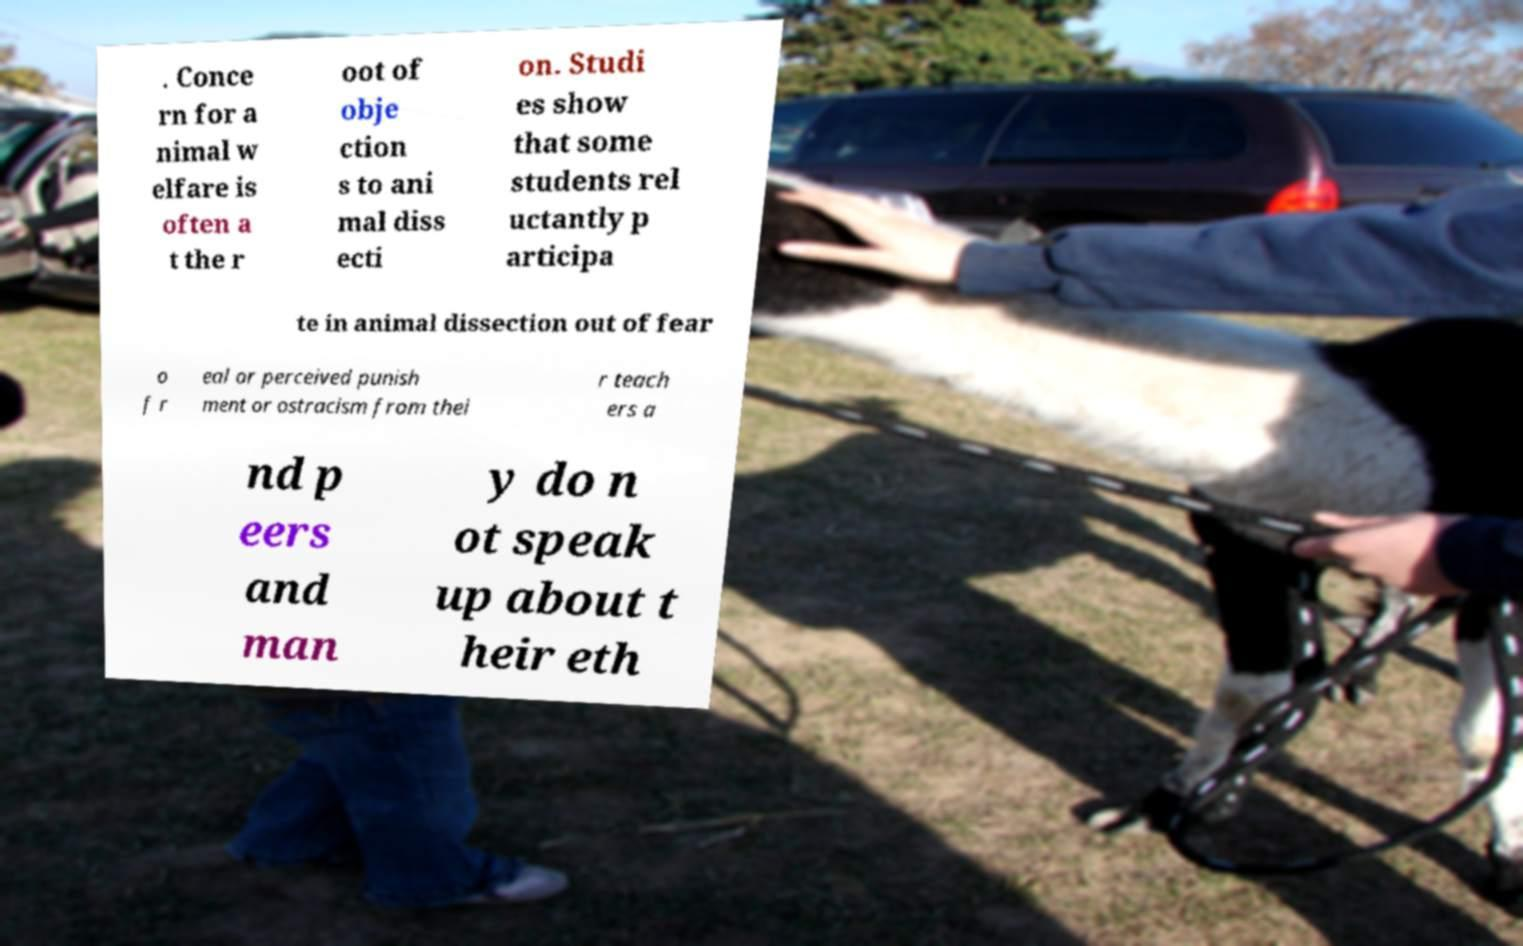Could you extract and type out the text from this image? . Conce rn for a nimal w elfare is often a t the r oot of obje ction s to ani mal diss ecti on. Studi es show that some students rel uctantly p articipa te in animal dissection out of fear o f r eal or perceived punish ment or ostracism from thei r teach ers a nd p eers and man y do n ot speak up about t heir eth 